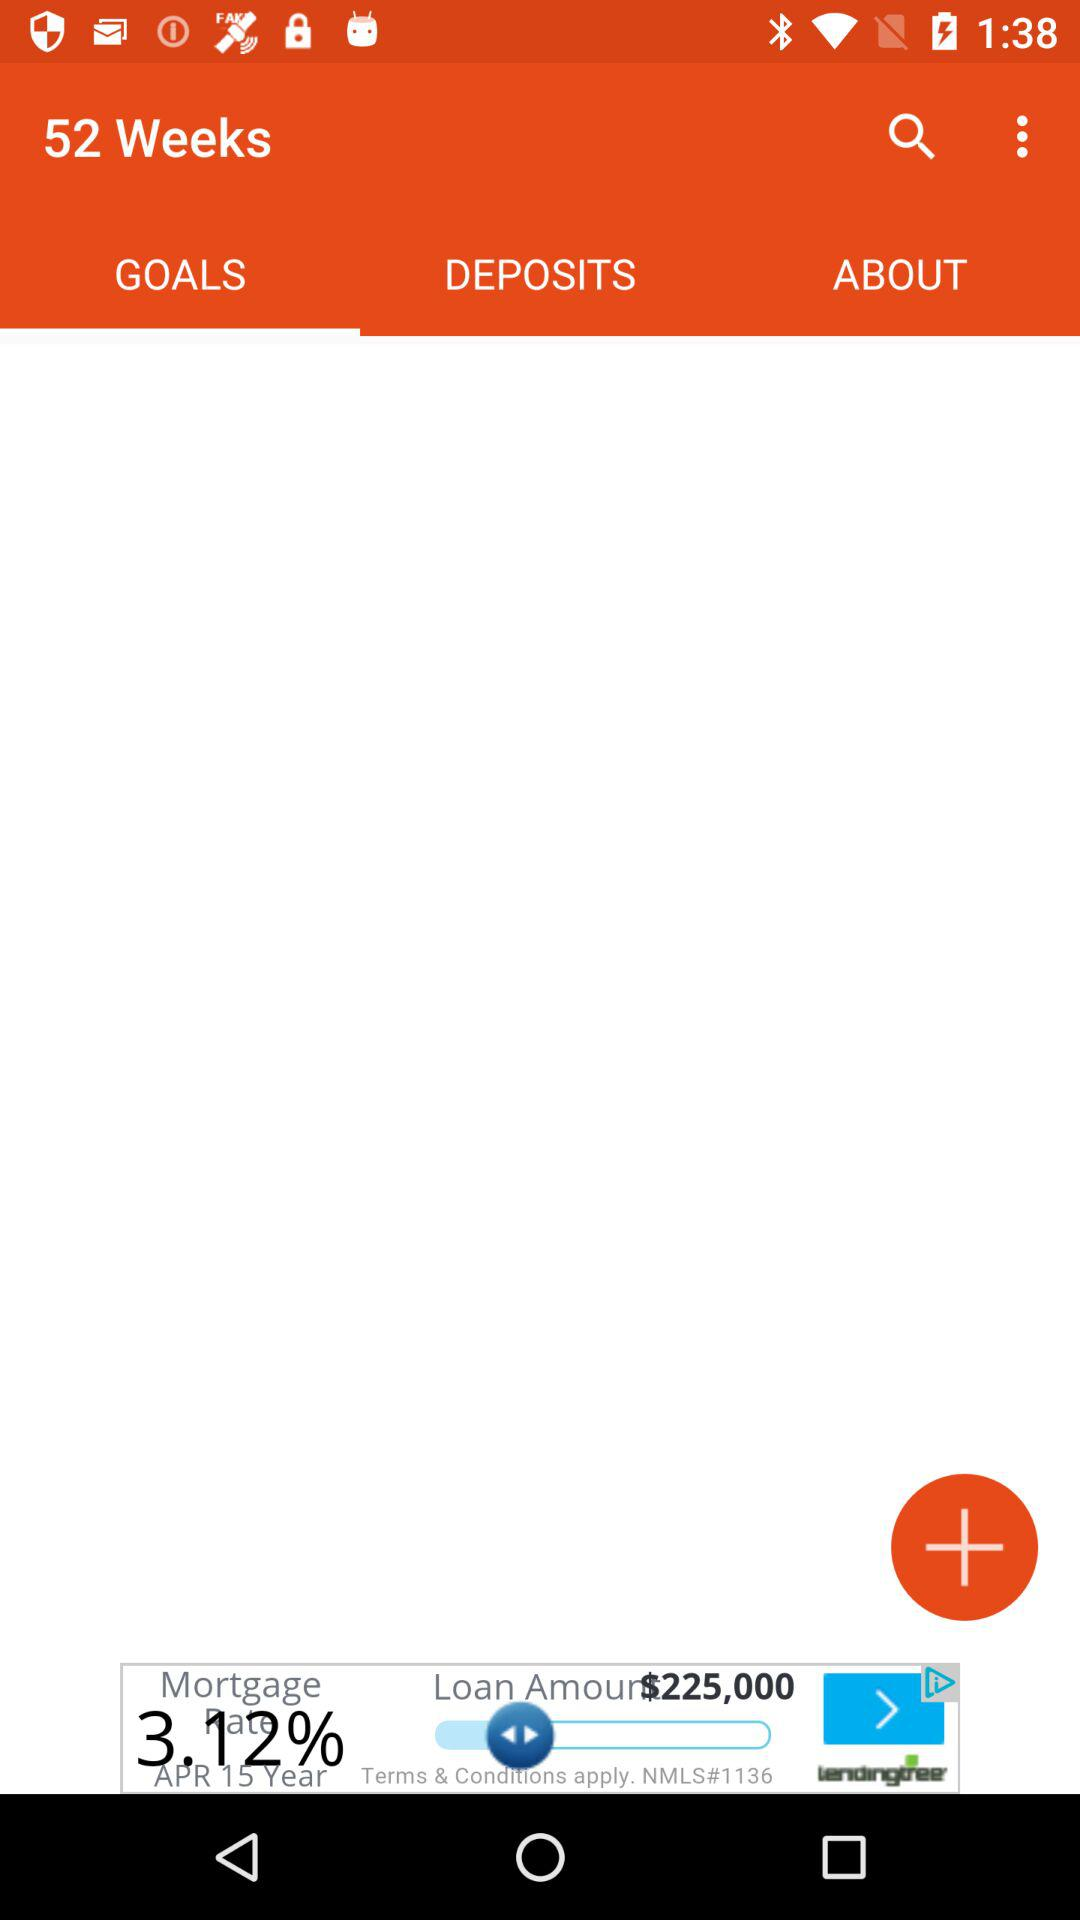What is the given duration? The given duration is 52 weeks. 